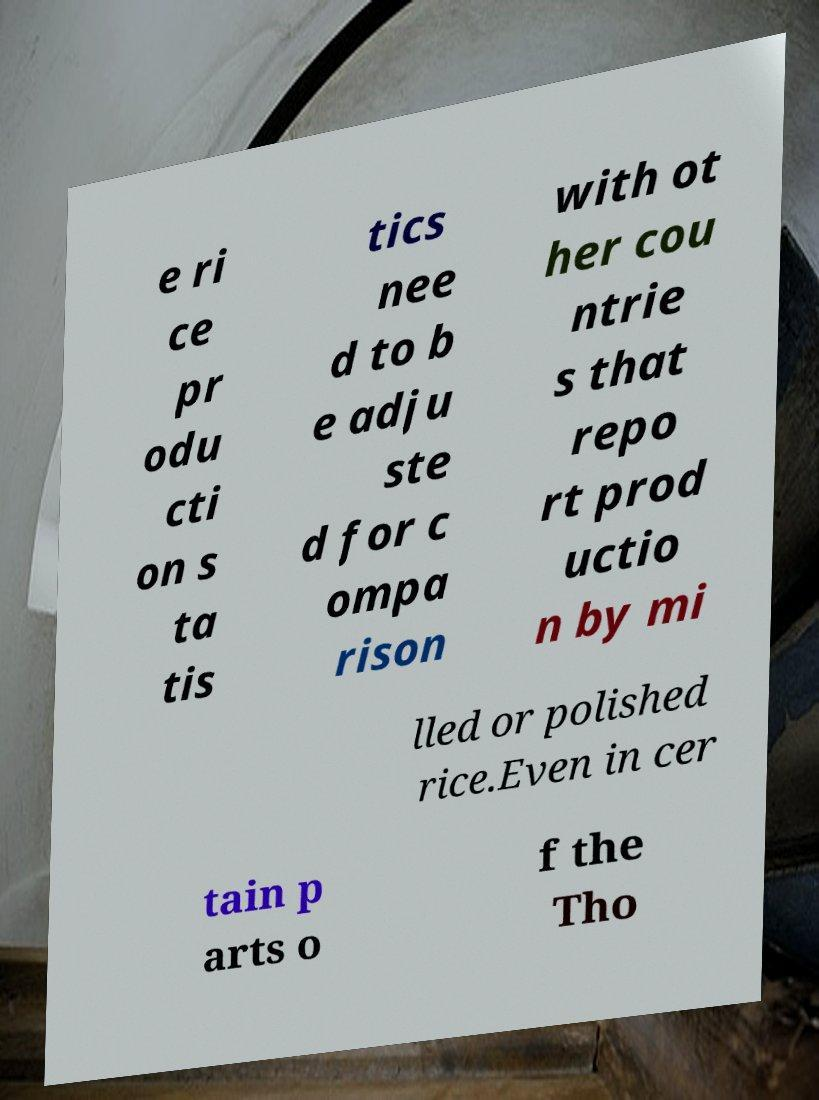Please identify and transcribe the text found in this image. e ri ce pr odu cti on s ta tis tics nee d to b e adju ste d for c ompa rison with ot her cou ntrie s that repo rt prod uctio n by mi lled or polished rice.Even in cer tain p arts o f the Tho 